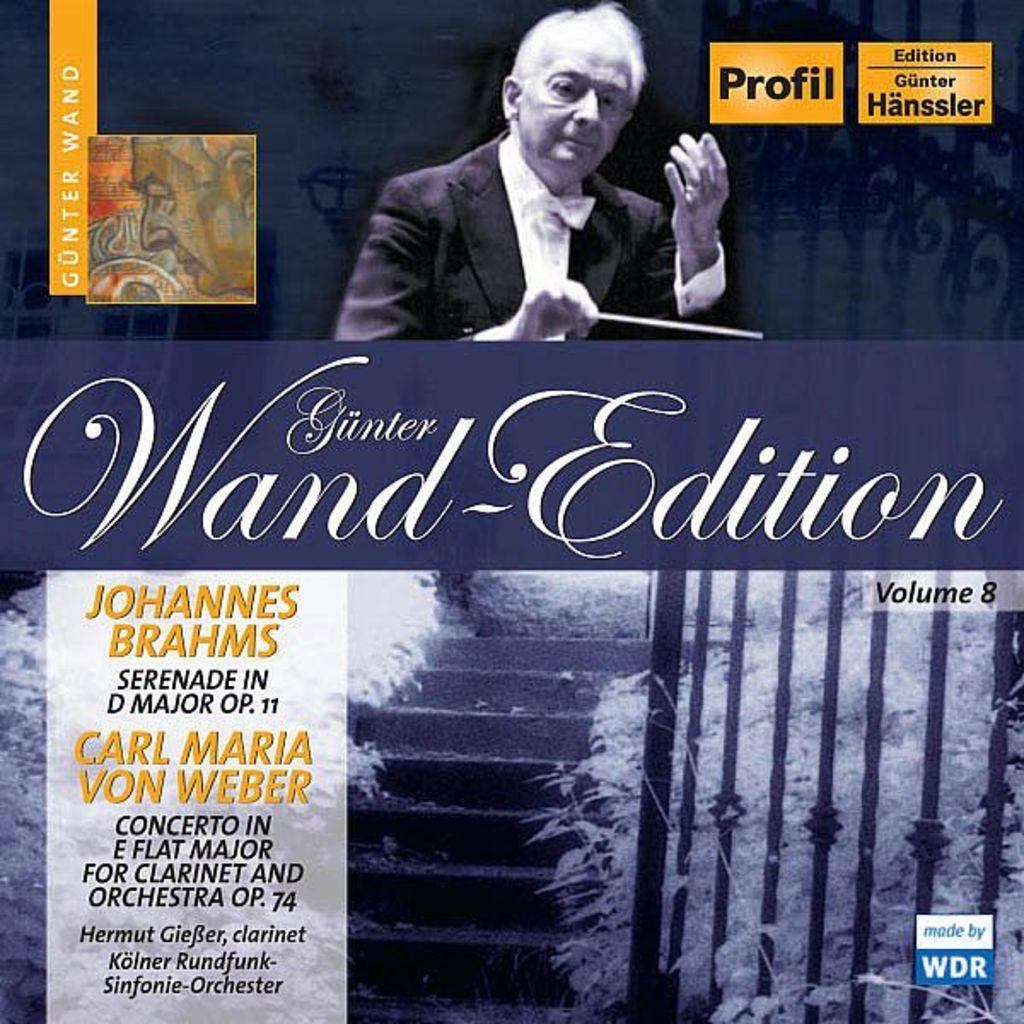<image>
Describe the image concisely. Johannes Brahms music has a made by WDR logo in the corner. 